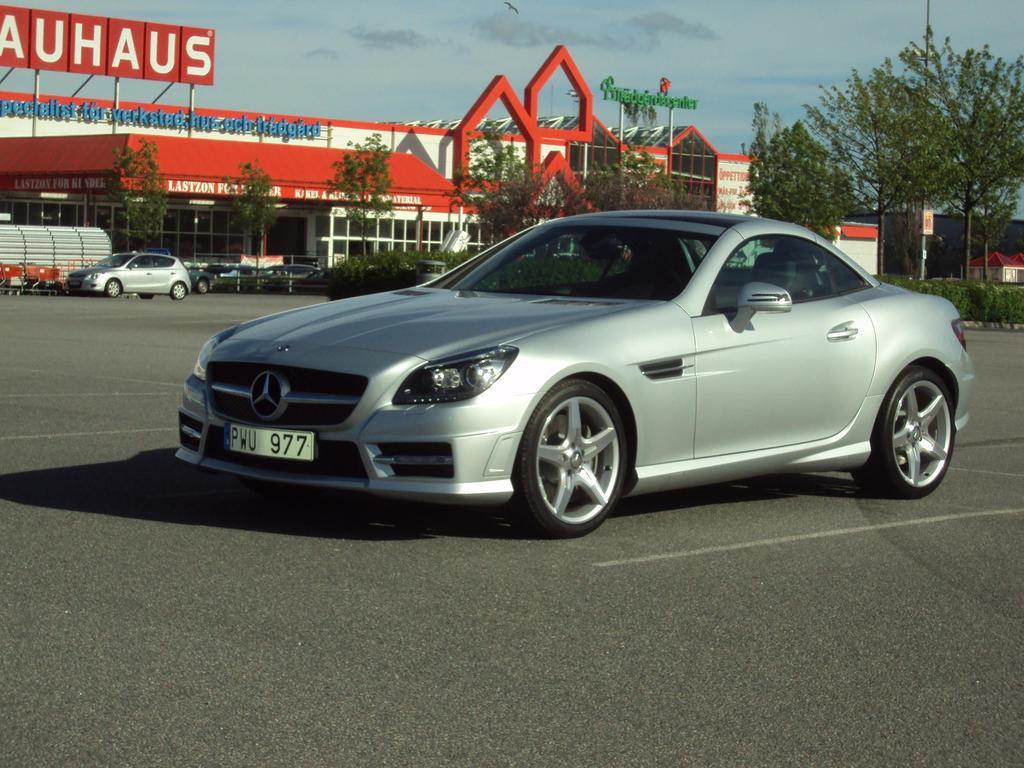Provide a one-sentence caption for the provided image. Gray car is parked in the parking lot near a sign that reads auhaus. 